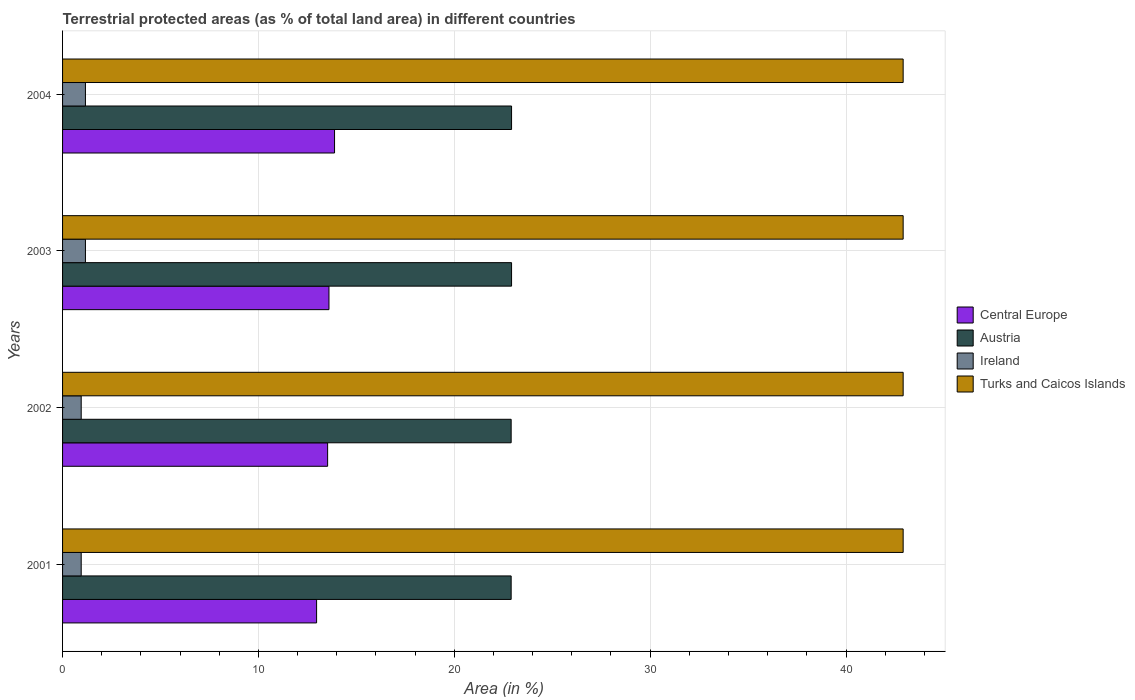How many different coloured bars are there?
Keep it short and to the point. 4. How many groups of bars are there?
Make the answer very short. 4. Are the number of bars per tick equal to the number of legend labels?
Offer a very short reply. Yes. How many bars are there on the 2nd tick from the bottom?
Make the answer very short. 4. What is the label of the 3rd group of bars from the top?
Provide a succinct answer. 2002. In how many cases, is the number of bars for a given year not equal to the number of legend labels?
Provide a succinct answer. 0. What is the percentage of terrestrial protected land in Ireland in 2002?
Provide a short and direct response. 0.95. Across all years, what is the maximum percentage of terrestrial protected land in Central Europe?
Offer a terse response. 13.89. Across all years, what is the minimum percentage of terrestrial protected land in Austria?
Your response must be concise. 22.9. What is the total percentage of terrestrial protected land in Central Europe in the graph?
Offer a terse response. 53.99. What is the difference between the percentage of terrestrial protected land in Ireland in 2002 and that in 2003?
Provide a succinct answer. -0.22. What is the difference between the percentage of terrestrial protected land in Ireland in 2004 and the percentage of terrestrial protected land in Central Europe in 2001?
Offer a very short reply. -11.8. What is the average percentage of terrestrial protected land in Austria per year?
Provide a succinct answer. 22.91. In the year 2001, what is the difference between the percentage of terrestrial protected land in Ireland and percentage of terrestrial protected land in Central Europe?
Provide a succinct answer. -12.02. In how many years, is the percentage of terrestrial protected land in Turks and Caicos Islands greater than 32 %?
Make the answer very short. 4. What is the ratio of the percentage of terrestrial protected land in Austria in 2002 to that in 2003?
Ensure brevity in your answer.  1. Is the difference between the percentage of terrestrial protected land in Ireland in 2001 and 2002 greater than the difference between the percentage of terrestrial protected land in Central Europe in 2001 and 2002?
Make the answer very short. Yes. What is the difference between the highest and the second highest percentage of terrestrial protected land in Central Europe?
Give a very brief answer. 0.29. What is the difference between the highest and the lowest percentage of terrestrial protected land in Austria?
Provide a short and direct response. 0.02. In how many years, is the percentage of terrestrial protected land in Austria greater than the average percentage of terrestrial protected land in Austria taken over all years?
Your answer should be very brief. 2. Is the sum of the percentage of terrestrial protected land in Ireland in 2001 and 2003 greater than the maximum percentage of terrestrial protected land in Turks and Caicos Islands across all years?
Your answer should be compact. No. Is it the case that in every year, the sum of the percentage of terrestrial protected land in Ireland and percentage of terrestrial protected land in Austria is greater than the sum of percentage of terrestrial protected land in Turks and Caicos Islands and percentage of terrestrial protected land in Central Europe?
Offer a very short reply. No. What does the 2nd bar from the top in 2003 represents?
Ensure brevity in your answer.  Ireland. What does the 1st bar from the bottom in 2003 represents?
Give a very brief answer. Central Europe. Is it the case that in every year, the sum of the percentage of terrestrial protected land in Turks and Caicos Islands and percentage of terrestrial protected land in Austria is greater than the percentage of terrestrial protected land in Ireland?
Give a very brief answer. Yes. Are all the bars in the graph horizontal?
Keep it short and to the point. Yes. How many years are there in the graph?
Your response must be concise. 4. What is the difference between two consecutive major ticks on the X-axis?
Make the answer very short. 10. Are the values on the major ticks of X-axis written in scientific E-notation?
Your answer should be compact. No. Does the graph contain any zero values?
Your response must be concise. No. Does the graph contain grids?
Your response must be concise. Yes. How are the legend labels stacked?
Ensure brevity in your answer.  Vertical. What is the title of the graph?
Offer a very short reply. Terrestrial protected areas (as % of total land area) in different countries. Does "Romania" appear as one of the legend labels in the graph?
Your answer should be very brief. No. What is the label or title of the X-axis?
Your answer should be very brief. Area (in %). What is the Area (in %) in Central Europe in 2001?
Your response must be concise. 12.97. What is the Area (in %) in Austria in 2001?
Make the answer very short. 22.9. What is the Area (in %) of Ireland in 2001?
Give a very brief answer. 0.95. What is the Area (in %) of Turks and Caicos Islands in 2001?
Make the answer very short. 42.92. What is the Area (in %) of Central Europe in 2002?
Your answer should be very brief. 13.53. What is the Area (in %) of Austria in 2002?
Give a very brief answer. 22.9. What is the Area (in %) of Ireland in 2002?
Give a very brief answer. 0.95. What is the Area (in %) of Turks and Caicos Islands in 2002?
Your answer should be compact. 42.92. What is the Area (in %) of Central Europe in 2003?
Provide a short and direct response. 13.6. What is the Area (in %) of Austria in 2003?
Provide a short and direct response. 22.92. What is the Area (in %) in Ireland in 2003?
Your answer should be compact. 1.17. What is the Area (in %) of Turks and Caicos Islands in 2003?
Your answer should be very brief. 42.92. What is the Area (in %) in Central Europe in 2004?
Your answer should be compact. 13.89. What is the Area (in %) of Austria in 2004?
Offer a terse response. 22.92. What is the Area (in %) in Ireland in 2004?
Provide a succinct answer. 1.17. What is the Area (in %) of Turks and Caicos Islands in 2004?
Your answer should be compact. 42.92. Across all years, what is the maximum Area (in %) of Central Europe?
Provide a short and direct response. 13.89. Across all years, what is the maximum Area (in %) of Austria?
Make the answer very short. 22.92. Across all years, what is the maximum Area (in %) of Ireland?
Make the answer very short. 1.17. Across all years, what is the maximum Area (in %) in Turks and Caicos Islands?
Offer a terse response. 42.92. Across all years, what is the minimum Area (in %) in Central Europe?
Your answer should be compact. 12.97. Across all years, what is the minimum Area (in %) of Austria?
Provide a short and direct response. 22.9. Across all years, what is the minimum Area (in %) of Ireland?
Give a very brief answer. 0.95. Across all years, what is the minimum Area (in %) in Turks and Caicos Islands?
Provide a short and direct response. 42.92. What is the total Area (in %) of Central Europe in the graph?
Keep it short and to the point. 53.99. What is the total Area (in %) in Austria in the graph?
Provide a short and direct response. 91.66. What is the total Area (in %) of Ireland in the graph?
Keep it short and to the point. 4.24. What is the total Area (in %) of Turks and Caicos Islands in the graph?
Give a very brief answer. 171.67. What is the difference between the Area (in %) in Central Europe in 2001 and that in 2002?
Provide a short and direct response. -0.56. What is the difference between the Area (in %) in Austria in 2001 and that in 2002?
Ensure brevity in your answer.  -0. What is the difference between the Area (in %) of Turks and Caicos Islands in 2001 and that in 2002?
Your answer should be compact. 0. What is the difference between the Area (in %) in Central Europe in 2001 and that in 2003?
Ensure brevity in your answer.  -0.63. What is the difference between the Area (in %) in Austria in 2001 and that in 2003?
Your answer should be very brief. -0.02. What is the difference between the Area (in %) in Ireland in 2001 and that in 2003?
Give a very brief answer. -0.22. What is the difference between the Area (in %) of Turks and Caicos Islands in 2001 and that in 2003?
Your response must be concise. 0. What is the difference between the Area (in %) in Central Europe in 2001 and that in 2004?
Keep it short and to the point. -0.92. What is the difference between the Area (in %) of Austria in 2001 and that in 2004?
Your answer should be very brief. -0.02. What is the difference between the Area (in %) of Ireland in 2001 and that in 2004?
Your answer should be very brief. -0.22. What is the difference between the Area (in %) of Turks and Caicos Islands in 2001 and that in 2004?
Ensure brevity in your answer.  0. What is the difference between the Area (in %) of Central Europe in 2002 and that in 2003?
Make the answer very short. -0.07. What is the difference between the Area (in %) in Austria in 2002 and that in 2003?
Provide a succinct answer. -0.02. What is the difference between the Area (in %) in Ireland in 2002 and that in 2003?
Provide a succinct answer. -0.22. What is the difference between the Area (in %) of Turks and Caicos Islands in 2002 and that in 2003?
Your answer should be very brief. 0. What is the difference between the Area (in %) of Central Europe in 2002 and that in 2004?
Provide a short and direct response. -0.35. What is the difference between the Area (in %) in Austria in 2002 and that in 2004?
Keep it short and to the point. -0.02. What is the difference between the Area (in %) in Ireland in 2002 and that in 2004?
Provide a short and direct response. -0.22. What is the difference between the Area (in %) in Central Europe in 2003 and that in 2004?
Your response must be concise. -0.29. What is the difference between the Area (in %) of Austria in 2003 and that in 2004?
Your answer should be compact. 0. What is the difference between the Area (in %) of Ireland in 2003 and that in 2004?
Give a very brief answer. 0. What is the difference between the Area (in %) in Central Europe in 2001 and the Area (in %) in Austria in 2002?
Your answer should be very brief. -9.93. What is the difference between the Area (in %) of Central Europe in 2001 and the Area (in %) of Ireland in 2002?
Make the answer very short. 12.02. What is the difference between the Area (in %) of Central Europe in 2001 and the Area (in %) of Turks and Caicos Islands in 2002?
Your answer should be very brief. -29.95. What is the difference between the Area (in %) in Austria in 2001 and the Area (in %) in Ireland in 2002?
Keep it short and to the point. 21.95. What is the difference between the Area (in %) of Austria in 2001 and the Area (in %) of Turks and Caicos Islands in 2002?
Provide a short and direct response. -20.01. What is the difference between the Area (in %) in Ireland in 2001 and the Area (in %) in Turks and Caicos Islands in 2002?
Offer a very short reply. -41.97. What is the difference between the Area (in %) of Central Europe in 2001 and the Area (in %) of Austria in 2003?
Provide a short and direct response. -9.95. What is the difference between the Area (in %) of Central Europe in 2001 and the Area (in %) of Ireland in 2003?
Keep it short and to the point. 11.8. What is the difference between the Area (in %) of Central Europe in 2001 and the Area (in %) of Turks and Caicos Islands in 2003?
Make the answer very short. -29.95. What is the difference between the Area (in %) in Austria in 2001 and the Area (in %) in Ireland in 2003?
Provide a short and direct response. 21.74. What is the difference between the Area (in %) in Austria in 2001 and the Area (in %) in Turks and Caicos Islands in 2003?
Provide a succinct answer. -20.01. What is the difference between the Area (in %) in Ireland in 2001 and the Area (in %) in Turks and Caicos Islands in 2003?
Give a very brief answer. -41.97. What is the difference between the Area (in %) in Central Europe in 2001 and the Area (in %) in Austria in 2004?
Your response must be concise. -9.95. What is the difference between the Area (in %) of Central Europe in 2001 and the Area (in %) of Ireland in 2004?
Provide a succinct answer. 11.8. What is the difference between the Area (in %) in Central Europe in 2001 and the Area (in %) in Turks and Caicos Islands in 2004?
Make the answer very short. -29.95. What is the difference between the Area (in %) in Austria in 2001 and the Area (in %) in Ireland in 2004?
Keep it short and to the point. 21.74. What is the difference between the Area (in %) of Austria in 2001 and the Area (in %) of Turks and Caicos Islands in 2004?
Your response must be concise. -20.01. What is the difference between the Area (in %) of Ireland in 2001 and the Area (in %) of Turks and Caicos Islands in 2004?
Give a very brief answer. -41.97. What is the difference between the Area (in %) in Central Europe in 2002 and the Area (in %) in Austria in 2003?
Your response must be concise. -9.39. What is the difference between the Area (in %) of Central Europe in 2002 and the Area (in %) of Ireland in 2003?
Offer a terse response. 12.37. What is the difference between the Area (in %) in Central Europe in 2002 and the Area (in %) in Turks and Caicos Islands in 2003?
Offer a very short reply. -29.38. What is the difference between the Area (in %) in Austria in 2002 and the Area (in %) in Ireland in 2003?
Offer a very short reply. 21.74. What is the difference between the Area (in %) of Austria in 2002 and the Area (in %) of Turks and Caicos Islands in 2003?
Provide a succinct answer. -20.01. What is the difference between the Area (in %) in Ireland in 2002 and the Area (in %) in Turks and Caicos Islands in 2003?
Offer a terse response. -41.97. What is the difference between the Area (in %) of Central Europe in 2002 and the Area (in %) of Austria in 2004?
Offer a terse response. -9.39. What is the difference between the Area (in %) in Central Europe in 2002 and the Area (in %) in Ireland in 2004?
Provide a short and direct response. 12.37. What is the difference between the Area (in %) of Central Europe in 2002 and the Area (in %) of Turks and Caicos Islands in 2004?
Ensure brevity in your answer.  -29.38. What is the difference between the Area (in %) of Austria in 2002 and the Area (in %) of Ireland in 2004?
Provide a short and direct response. 21.74. What is the difference between the Area (in %) in Austria in 2002 and the Area (in %) in Turks and Caicos Islands in 2004?
Offer a terse response. -20.01. What is the difference between the Area (in %) in Ireland in 2002 and the Area (in %) in Turks and Caicos Islands in 2004?
Provide a short and direct response. -41.97. What is the difference between the Area (in %) of Central Europe in 2003 and the Area (in %) of Austria in 2004?
Ensure brevity in your answer.  -9.32. What is the difference between the Area (in %) of Central Europe in 2003 and the Area (in %) of Ireland in 2004?
Offer a terse response. 12.43. What is the difference between the Area (in %) of Central Europe in 2003 and the Area (in %) of Turks and Caicos Islands in 2004?
Offer a terse response. -29.32. What is the difference between the Area (in %) of Austria in 2003 and the Area (in %) of Ireland in 2004?
Provide a succinct answer. 21.76. What is the difference between the Area (in %) of Austria in 2003 and the Area (in %) of Turks and Caicos Islands in 2004?
Give a very brief answer. -19.99. What is the difference between the Area (in %) of Ireland in 2003 and the Area (in %) of Turks and Caicos Islands in 2004?
Make the answer very short. -41.75. What is the average Area (in %) of Central Europe per year?
Your response must be concise. 13.5. What is the average Area (in %) of Austria per year?
Provide a short and direct response. 22.91. What is the average Area (in %) in Ireland per year?
Offer a terse response. 1.06. What is the average Area (in %) of Turks and Caicos Islands per year?
Your answer should be compact. 42.92. In the year 2001, what is the difference between the Area (in %) of Central Europe and Area (in %) of Austria?
Your answer should be very brief. -9.93. In the year 2001, what is the difference between the Area (in %) in Central Europe and Area (in %) in Ireland?
Make the answer very short. 12.02. In the year 2001, what is the difference between the Area (in %) of Central Europe and Area (in %) of Turks and Caicos Islands?
Give a very brief answer. -29.95. In the year 2001, what is the difference between the Area (in %) in Austria and Area (in %) in Ireland?
Your response must be concise. 21.95. In the year 2001, what is the difference between the Area (in %) of Austria and Area (in %) of Turks and Caicos Islands?
Provide a succinct answer. -20.01. In the year 2001, what is the difference between the Area (in %) of Ireland and Area (in %) of Turks and Caicos Islands?
Offer a very short reply. -41.97. In the year 2002, what is the difference between the Area (in %) of Central Europe and Area (in %) of Austria?
Offer a very short reply. -9.37. In the year 2002, what is the difference between the Area (in %) in Central Europe and Area (in %) in Ireland?
Provide a short and direct response. 12.58. In the year 2002, what is the difference between the Area (in %) in Central Europe and Area (in %) in Turks and Caicos Islands?
Offer a very short reply. -29.38. In the year 2002, what is the difference between the Area (in %) of Austria and Area (in %) of Ireland?
Ensure brevity in your answer.  21.95. In the year 2002, what is the difference between the Area (in %) of Austria and Area (in %) of Turks and Caicos Islands?
Provide a short and direct response. -20.01. In the year 2002, what is the difference between the Area (in %) of Ireland and Area (in %) of Turks and Caicos Islands?
Ensure brevity in your answer.  -41.97. In the year 2003, what is the difference between the Area (in %) of Central Europe and Area (in %) of Austria?
Keep it short and to the point. -9.32. In the year 2003, what is the difference between the Area (in %) of Central Europe and Area (in %) of Ireland?
Provide a succinct answer. 12.43. In the year 2003, what is the difference between the Area (in %) of Central Europe and Area (in %) of Turks and Caicos Islands?
Your answer should be very brief. -29.32. In the year 2003, what is the difference between the Area (in %) of Austria and Area (in %) of Ireland?
Offer a terse response. 21.76. In the year 2003, what is the difference between the Area (in %) of Austria and Area (in %) of Turks and Caicos Islands?
Keep it short and to the point. -19.99. In the year 2003, what is the difference between the Area (in %) in Ireland and Area (in %) in Turks and Caicos Islands?
Offer a very short reply. -41.75. In the year 2004, what is the difference between the Area (in %) in Central Europe and Area (in %) in Austria?
Offer a very short reply. -9.04. In the year 2004, what is the difference between the Area (in %) in Central Europe and Area (in %) in Ireland?
Give a very brief answer. 12.72. In the year 2004, what is the difference between the Area (in %) of Central Europe and Area (in %) of Turks and Caicos Islands?
Your response must be concise. -29.03. In the year 2004, what is the difference between the Area (in %) of Austria and Area (in %) of Ireland?
Make the answer very short. 21.76. In the year 2004, what is the difference between the Area (in %) in Austria and Area (in %) in Turks and Caicos Islands?
Your answer should be compact. -19.99. In the year 2004, what is the difference between the Area (in %) of Ireland and Area (in %) of Turks and Caicos Islands?
Keep it short and to the point. -41.75. What is the ratio of the Area (in %) in Central Europe in 2001 to that in 2002?
Your response must be concise. 0.96. What is the ratio of the Area (in %) of Austria in 2001 to that in 2002?
Your answer should be compact. 1. What is the ratio of the Area (in %) in Central Europe in 2001 to that in 2003?
Keep it short and to the point. 0.95. What is the ratio of the Area (in %) in Ireland in 2001 to that in 2003?
Your answer should be compact. 0.82. What is the ratio of the Area (in %) of Turks and Caicos Islands in 2001 to that in 2003?
Make the answer very short. 1. What is the ratio of the Area (in %) in Central Europe in 2001 to that in 2004?
Offer a very short reply. 0.93. What is the ratio of the Area (in %) in Ireland in 2001 to that in 2004?
Your response must be concise. 0.82. What is the ratio of the Area (in %) in Turks and Caicos Islands in 2001 to that in 2004?
Ensure brevity in your answer.  1. What is the ratio of the Area (in %) of Central Europe in 2002 to that in 2003?
Provide a succinct answer. 0.99. What is the ratio of the Area (in %) of Austria in 2002 to that in 2003?
Ensure brevity in your answer.  1. What is the ratio of the Area (in %) in Ireland in 2002 to that in 2003?
Your response must be concise. 0.82. What is the ratio of the Area (in %) in Turks and Caicos Islands in 2002 to that in 2003?
Ensure brevity in your answer.  1. What is the ratio of the Area (in %) of Central Europe in 2002 to that in 2004?
Keep it short and to the point. 0.97. What is the ratio of the Area (in %) of Ireland in 2002 to that in 2004?
Your answer should be compact. 0.82. What is the ratio of the Area (in %) of Central Europe in 2003 to that in 2004?
Make the answer very short. 0.98. What is the ratio of the Area (in %) of Ireland in 2003 to that in 2004?
Ensure brevity in your answer.  1. What is the ratio of the Area (in %) of Turks and Caicos Islands in 2003 to that in 2004?
Provide a short and direct response. 1. What is the difference between the highest and the second highest Area (in %) in Central Europe?
Your response must be concise. 0.29. What is the difference between the highest and the second highest Area (in %) of Turks and Caicos Islands?
Keep it short and to the point. 0. What is the difference between the highest and the lowest Area (in %) in Central Europe?
Your answer should be very brief. 0.92. What is the difference between the highest and the lowest Area (in %) in Austria?
Ensure brevity in your answer.  0.02. What is the difference between the highest and the lowest Area (in %) of Ireland?
Your answer should be compact. 0.22. What is the difference between the highest and the lowest Area (in %) in Turks and Caicos Islands?
Ensure brevity in your answer.  0. 